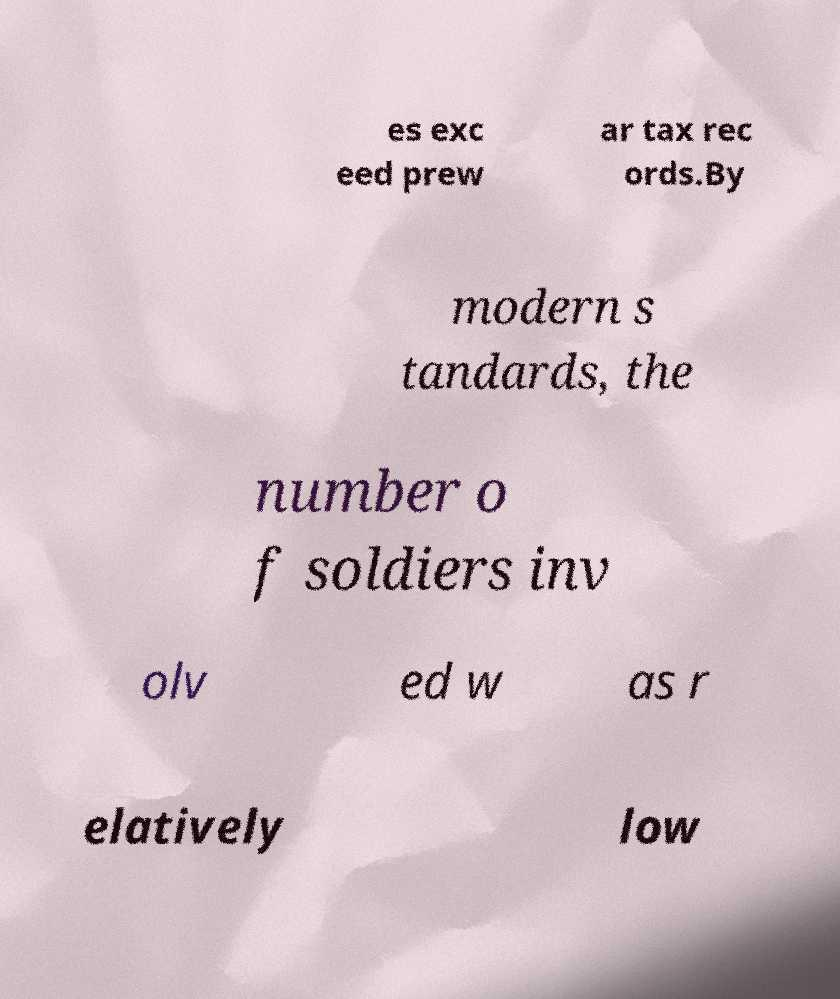I need the written content from this picture converted into text. Can you do that? es exc eed prew ar tax rec ords.By modern s tandards, the number o f soldiers inv olv ed w as r elatively low 